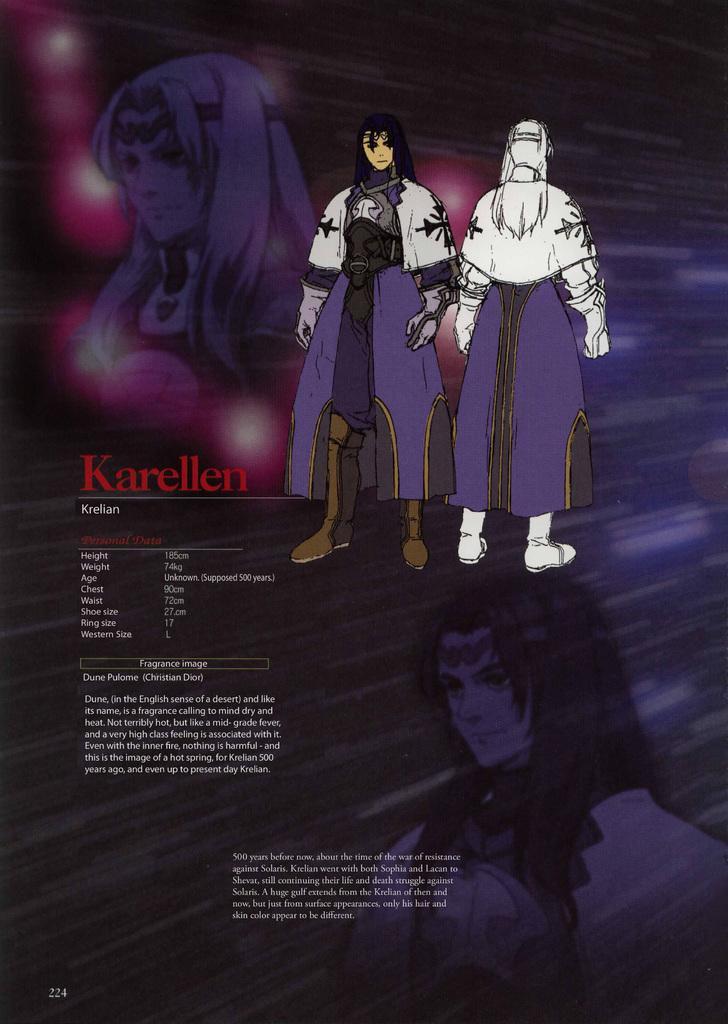Could you give a brief overview of what you see in this image? In the picture we can see a purple color cartoon magazine two cartoon men and some information beside it. 